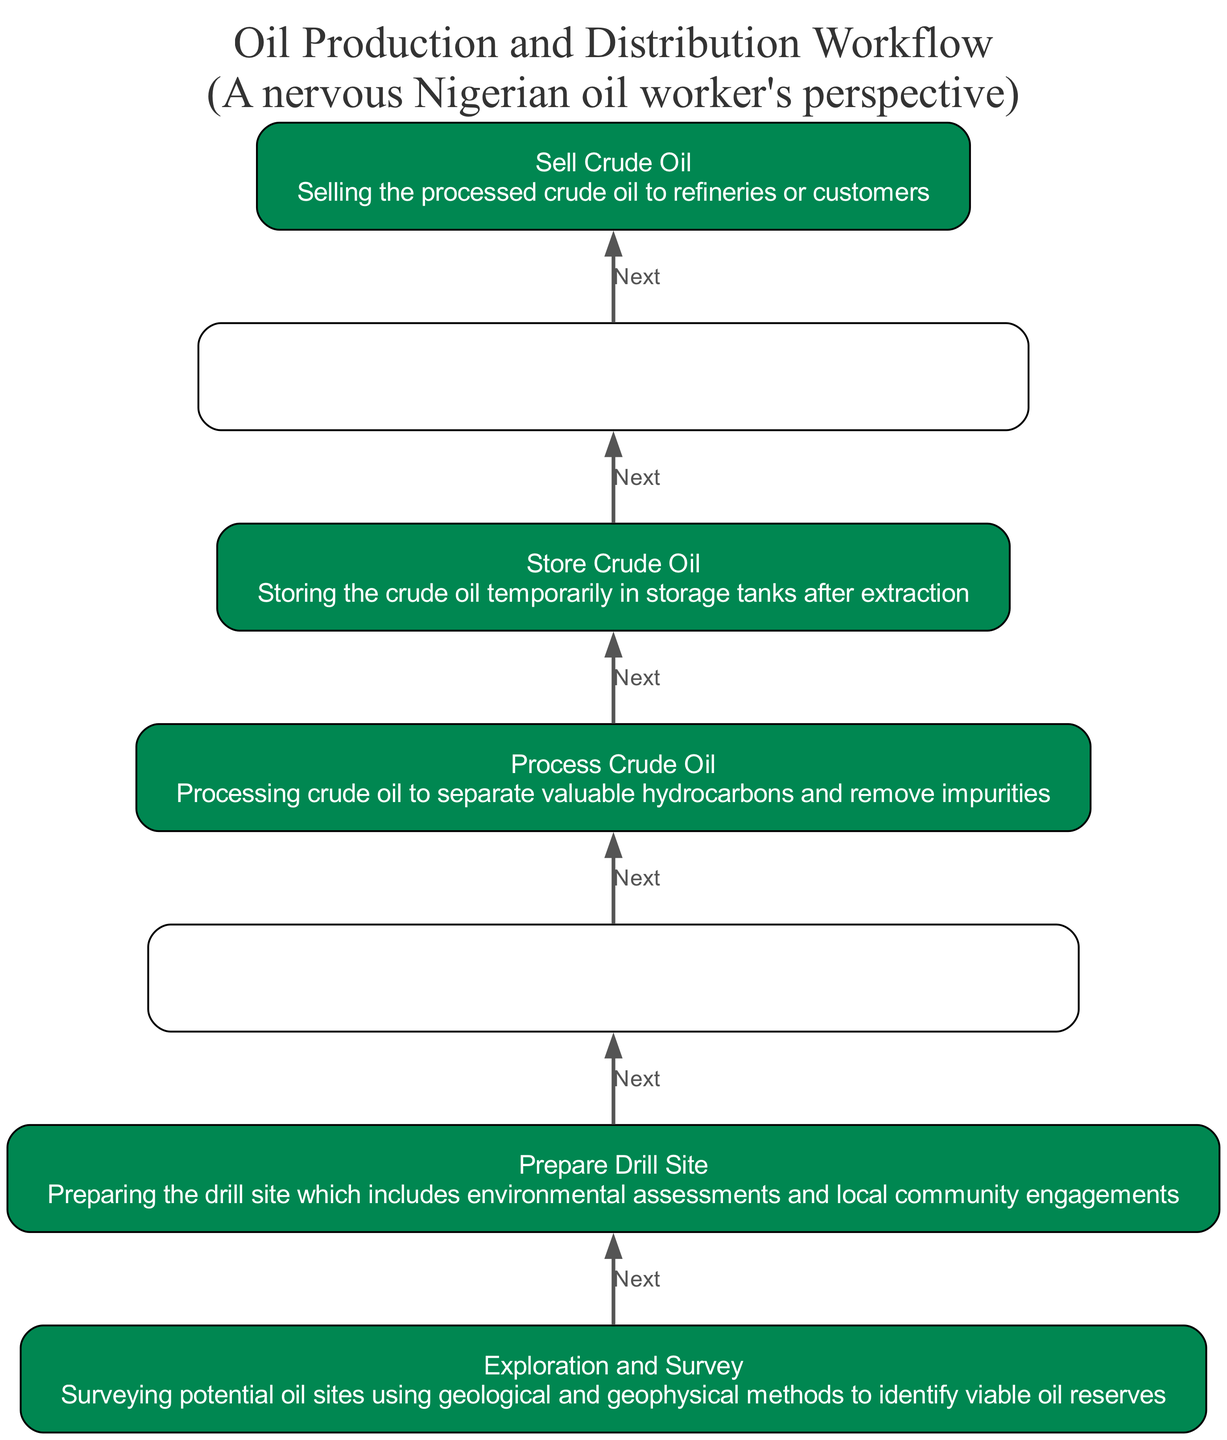What is the first step in the oil production workflow? The first step in the diagram is "Exploration and Survey," which is at the bottom of the flowchart, as it identifies viable oil reserves.
Answer: Exploration and Survey How many steps are there in the oil production workflow? By counting each distinct node in the diagram, there are 7 steps total that define the workflow from extraction to sales.
Answer: 7 What comes after "Process Crude Oil"? The node that follows "Process Crude Oil" is "Store Crude Oil," which indicates the flow from processing to storage in the workflow.
Answer: Store Crude Oil Which step involves engaging with local communities? "Prepare Drill Site" includes environmental assessments and local community engagements, making it the step focused on community interaction.
Answer: Prepare Drill Site What is the last step in the workflow? The final step indicated in the diagram is "Sell Crude Oil," which is the endpoint of the workflow where processed crude oil is sold to refineries or customers.
Answer: Sell Crude Oil Which two steps are directly connected to "Extract Crude Oil"? The two direct connections are "Prepare Drill Site" (leading to extraction) and "Process Crude Oil" (leading from extraction) as part of the workflow sequence.
Answer: Prepare Drill Site and Process Crude Oil What is the color scheme used in the diagram? The nodes in the diagram are colored using a palette based on the Nigerian flag, which consists of green, white, and green.
Answer: Green, white, and green What description is provided for "Transport Crude Oil"? The description for "Transport Crude Oil" states that it involves transporting crude oil via pipelines, ships, or trucks to refineries, reflecting its key processes in distribution.
Answer: Transporting the crude oil via pipelines, ships, or trucks to refineries 